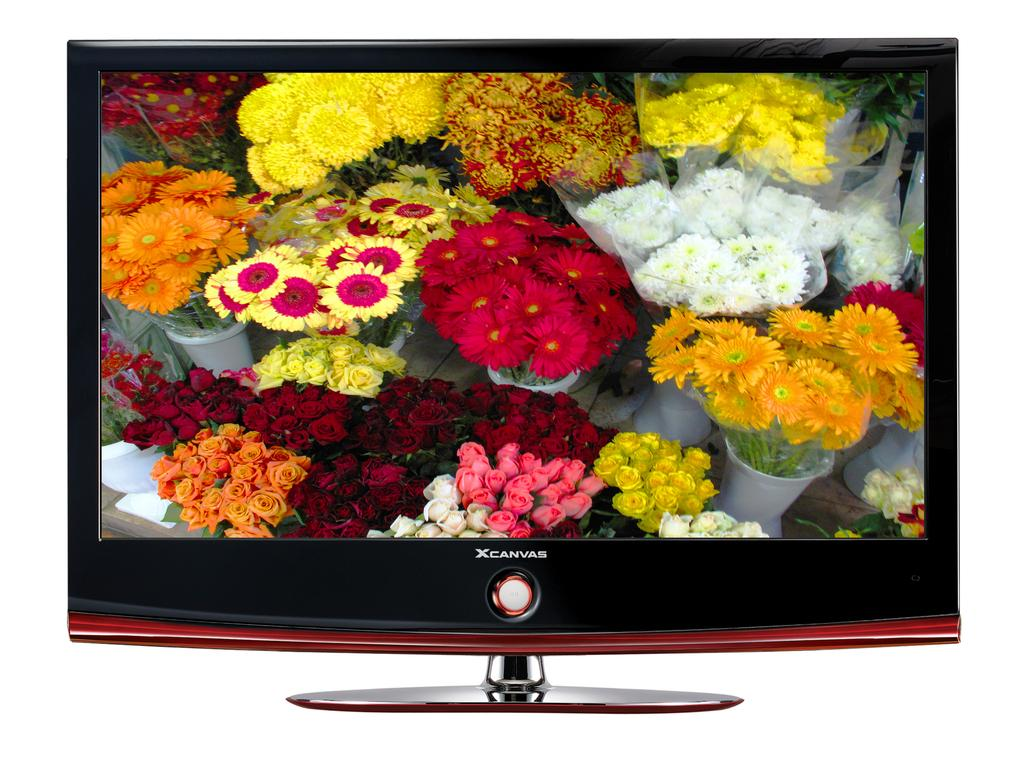<image>
Render a clear and concise summary of the photo. Television Screen of Flowers that say X Canvas on it. 